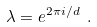<formula> <loc_0><loc_0><loc_500><loc_500>\lambda = e ^ { 2 \pi i / d } \ .</formula> 